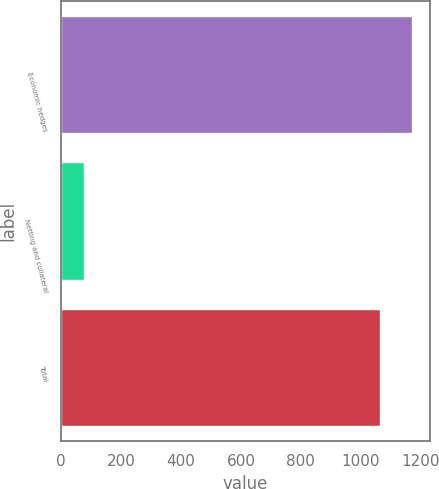Convert chart to OTSL. <chart><loc_0><loc_0><loc_500><loc_500><bar_chart><fcel>Economic hedges<fcel>Netting and collateral<fcel>Total<nl><fcel>1171.5<fcel>75<fcel>1065<nl></chart> 